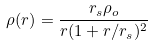Convert formula to latex. <formula><loc_0><loc_0><loc_500><loc_500>\rho ( r ) = \frac { r _ { s } \rho _ { o } } { r ( 1 + r / r _ { s } ) ^ { 2 } }</formula> 